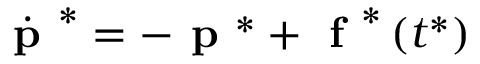<formula> <loc_0><loc_0><loc_500><loc_500>\begin{array} { r } { \dot { p } ^ { * } = - p ^ { * } + f ^ { * } \left ( t ^ { * } \right ) } \end{array}</formula> 